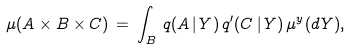<formula> <loc_0><loc_0><loc_500><loc_500>\mu ( A \times B \times C ) \, = \, \int _ { B } \, q ( A \, | \, Y ) \, q ^ { \prime } ( C \, | \, Y ) \, \mu ^ { y } ( d Y ) ,</formula> 